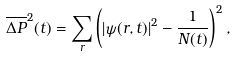Convert formula to latex. <formula><loc_0><loc_0><loc_500><loc_500>\overline { \Delta P } ^ { 2 } ( t ) = \sum _ { r } \left ( | \psi ( r , t ) | ^ { 2 } - \frac { 1 } { N ( t ) } \right ) ^ { 2 } ,</formula> 